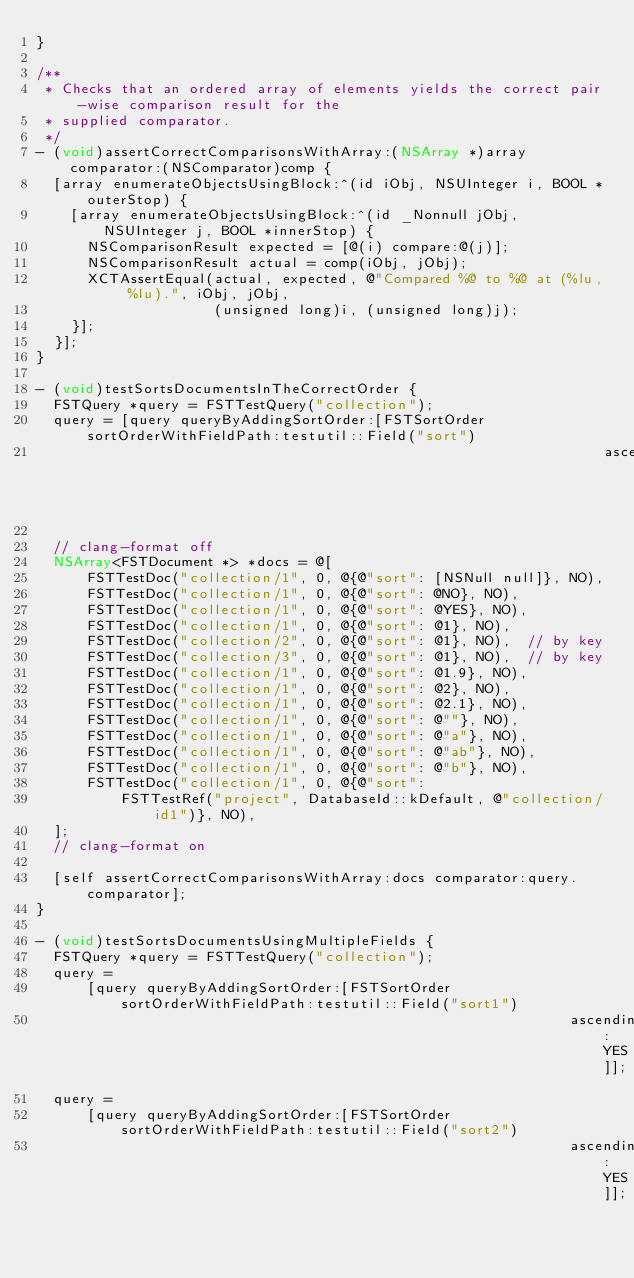<code> <loc_0><loc_0><loc_500><loc_500><_ObjectiveC_>}

/**
 * Checks that an ordered array of elements yields the correct pair-wise comparison result for the
 * supplied comparator.
 */
- (void)assertCorrectComparisonsWithArray:(NSArray *)array comparator:(NSComparator)comp {
  [array enumerateObjectsUsingBlock:^(id iObj, NSUInteger i, BOOL *outerStop) {
    [array enumerateObjectsUsingBlock:^(id _Nonnull jObj, NSUInteger j, BOOL *innerStop) {
      NSComparisonResult expected = [@(i) compare:@(j)];
      NSComparisonResult actual = comp(iObj, jObj);
      XCTAssertEqual(actual, expected, @"Compared %@ to %@ at (%lu, %lu).", iObj, jObj,
                     (unsigned long)i, (unsigned long)j);
    }];
  }];
}

- (void)testSortsDocumentsInTheCorrectOrder {
  FSTQuery *query = FSTTestQuery("collection");
  query = [query queryByAddingSortOrder:[FSTSortOrder sortOrderWithFieldPath:testutil::Field("sort")
                                                                   ascending:YES]];

  // clang-format off
  NSArray<FSTDocument *> *docs = @[
      FSTTestDoc("collection/1", 0, @{@"sort": [NSNull null]}, NO),
      FSTTestDoc("collection/1", 0, @{@"sort": @NO}, NO),
      FSTTestDoc("collection/1", 0, @{@"sort": @YES}, NO),
      FSTTestDoc("collection/1", 0, @{@"sort": @1}, NO),
      FSTTestDoc("collection/2", 0, @{@"sort": @1}, NO),  // by key
      FSTTestDoc("collection/3", 0, @{@"sort": @1}, NO),  // by key
      FSTTestDoc("collection/1", 0, @{@"sort": @1.9}, NO),
      FSTTestDoc("collection/1", 0, @{@"sort": @2}, NO),
      FSTTestDoc("collection/1", 0, @{@"sort": @2.1}, NO),
      FSTTestDoc("collection/1", 0, @{@"sort": @""}, NO),
      FSTTestDoc("collection/1", 0, @{@"sort": @"a"}, NO),
      FSTTestDoc("collection/1", 0, @{@"sort": @"ab"}, NO),
      FSTTestDoc("collection/1", 0, @{@"sort": @"b"}, NO),
      FSTTestDoc("collection/1", 0, @{@"sort":
          FSTTestRef("project", DatabaseId::kDefault, @"collection/id1")}, NO),
  ];
  // clang-format on

  [self assertCorrectComparisonsWithArray:docs comparator:query.comparator];
}

- (void)testSortsDocumentsUsingMultipleFields {
  FSTQuery *query = FSTTestQuery("collection");
  query =
      [query queryByAddingSortOrder:[FSTSortOrder sortOrderWithFieldPath:testutil::Field("sort1")
                                                               ascending:YES]];
  query =
      [query queryByAddingSortOrder:[FSTSortOrder sortOrderWithFieldPath:testutil::Field("sort2")
                                                               ascending:YES]];
</code> 